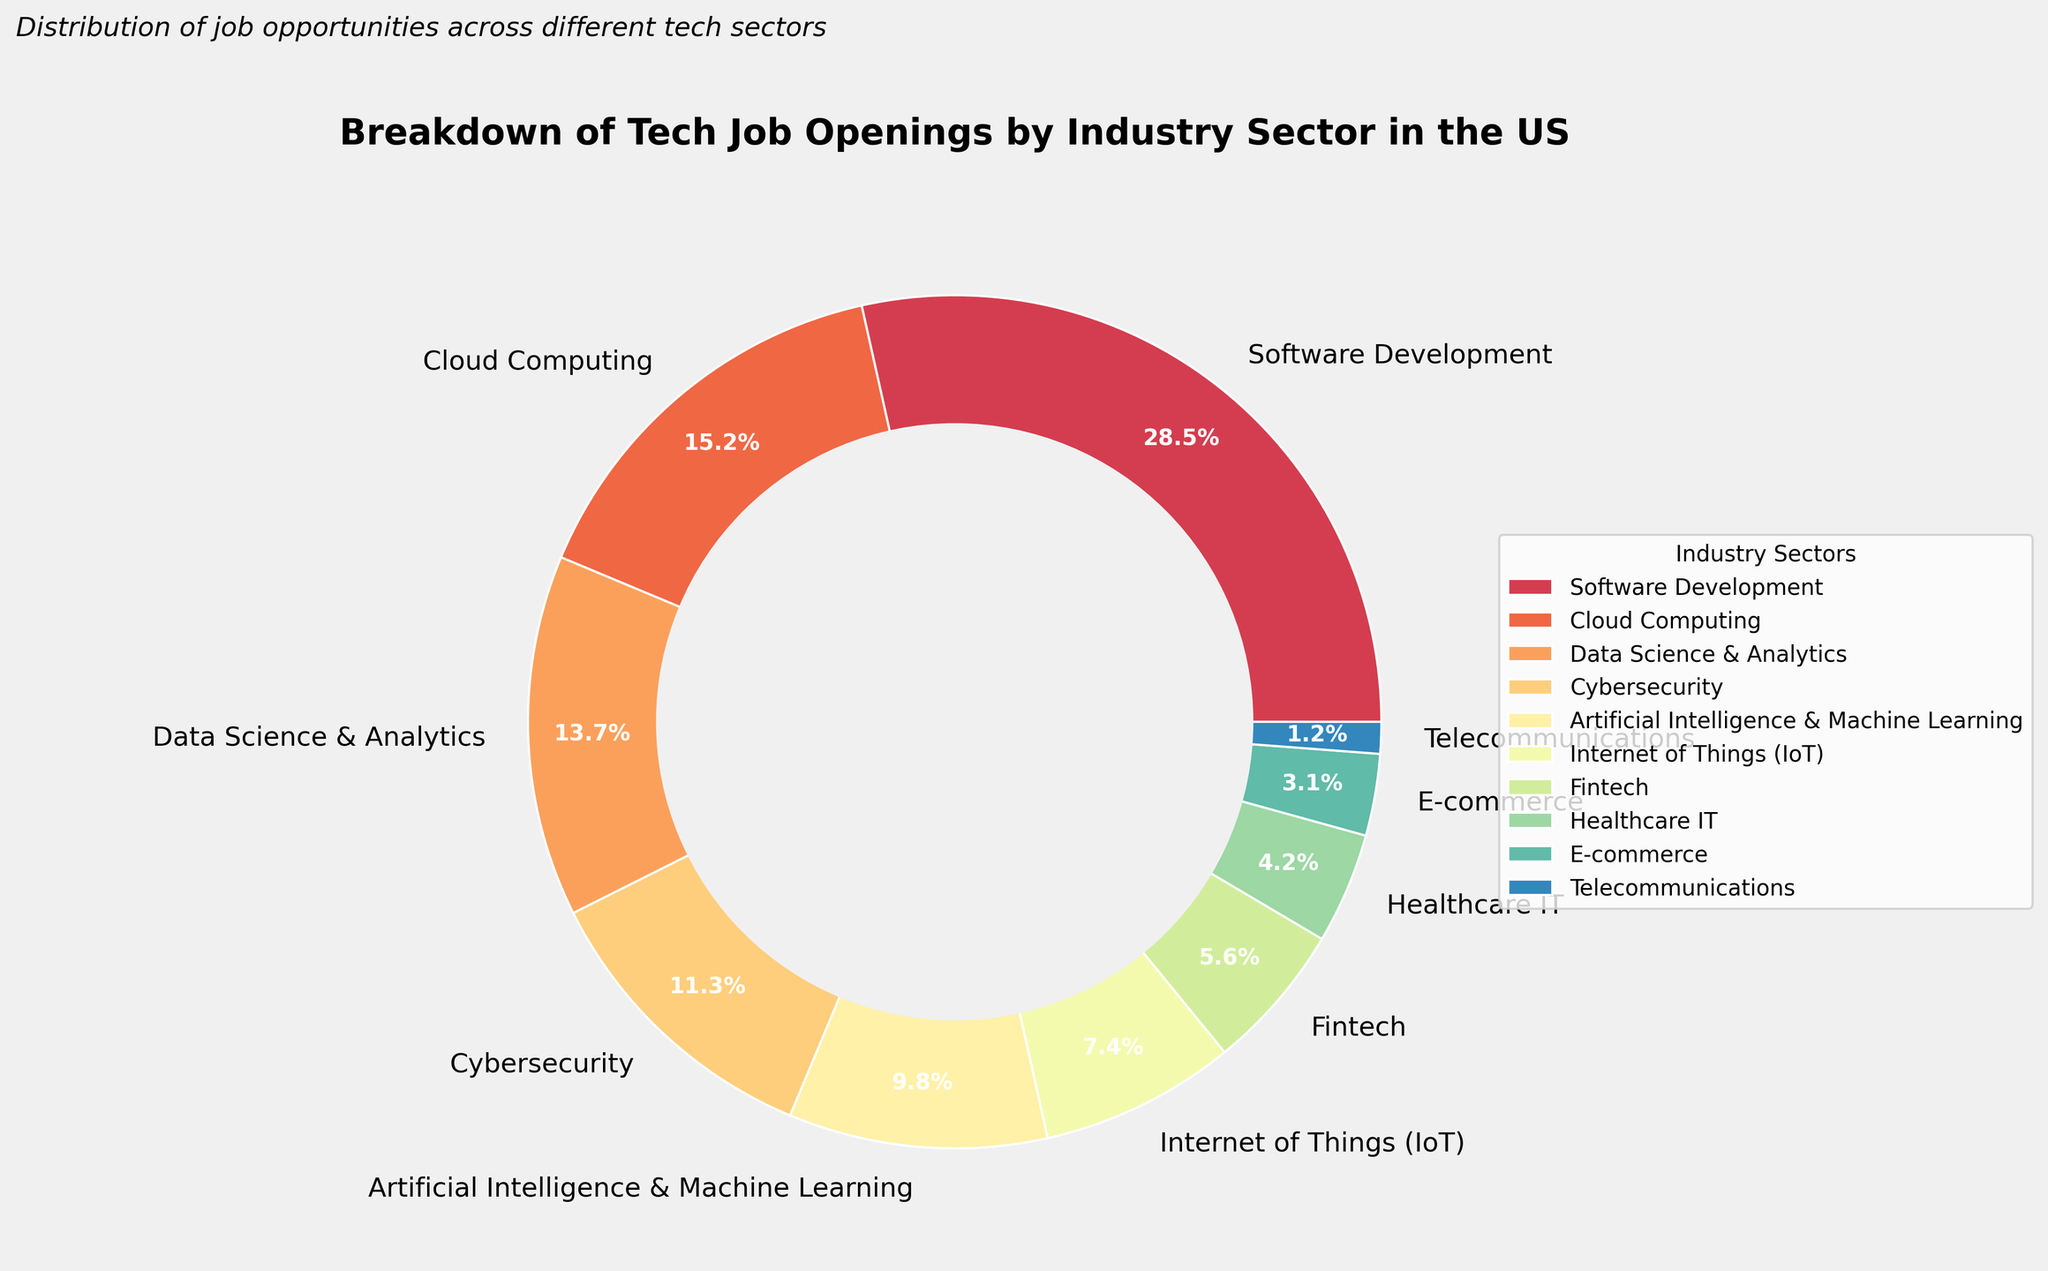What's the largest industry sector in the tech job openings? To find the largest industry sector, look at the segment with the highest percentage. The label "Software Development" shows 28.5%, which is the largest percentage on the pie chart.
Answer: Software Development Which industry sector has the smallest percentage of tech job openings? The smallest percentage corresponds to the label "Telecommunications," which shows 1.2%, the smallest value on the pie chart.
Answer: Telecommunications How much larger is the percentage of software development jobs compared to cloud computing jobs? The percentage for software development is 28.5% and for cloud computing is 15.2%. Subtract 15.2 from 28.5 to find the difference: 28.5 - 15.2 = 13.3%.
Answer: 13.3% What's the combined percentage of Data Science & Analytics, Cybersecurity, and Artificial Intelligence & Machine Learning jobs? Add the percentages for these three sectors: Data Science & Analytics (13.7%), Cybersecurity (11.3%), and Artificial Intelligence & Machine Learning (9.8%). The combined percentage is 13.7 + 11.3 + 9.8 = 34.8%.
Answer: 34.8% Is the percentage of Fintech jobs greater than Healthcare IT jobs? The pie chart shows Fintech at 5.6% and Healthcare IT at 4.2%. Comparing these values, 5.6% is greater than 4.2%.
Answer: Yes What's the percentage difference between Internet of Things (IoT) and E-commerce job openings? The percentage for Internet of Things (IoT) is 7.4% and for E-commerce is 3.1%. Subtract 3.1 from 7.4: 7.4 - 3.1 = 4.3%.
Answer: 4.3% Which sectors account for more than 10% of tech job openings? From the pie chart, sectors with percentages above 10% are Software Development (28.5%), Cloud Computing (15.2%), Data Science & Analytics (13.7%), and Cybersecurity (11.3%).
Answer: Software Development, Cloud Computing, Data Science & Analytics, Cybersecurity How much higher is the proportion of Cybersecurity jobs compared to Telecommunications jobs? Cybersecurity has 11.3% and Telecommunications has 1.2%. The difference is 11.3 - 1.2 = 10.1%.
Answer: 10.1% What is the average percentage of job openings for Artificial Intelligence & Machine Learning, Fintech, and E-commerce sectors combined? Add the percentages for these three sectors: AI & Machine Learning (9.8%), Fintech (5.6%), and E-commerce (3.1%), then divide by the number of sectors (3). The average is (9.8 + 5.6 + 3.1) / 3 ≈ 6.17%.
Answer: 6.17% Are there more jobs in Cloud Computing or in Data Science & Analytics? The percentage for Cloud Computing is 15.2% and for Data Science & Analytics it's 13.7%. 15.2% is greater than 13.7%.
Answer: Cloud Computing 